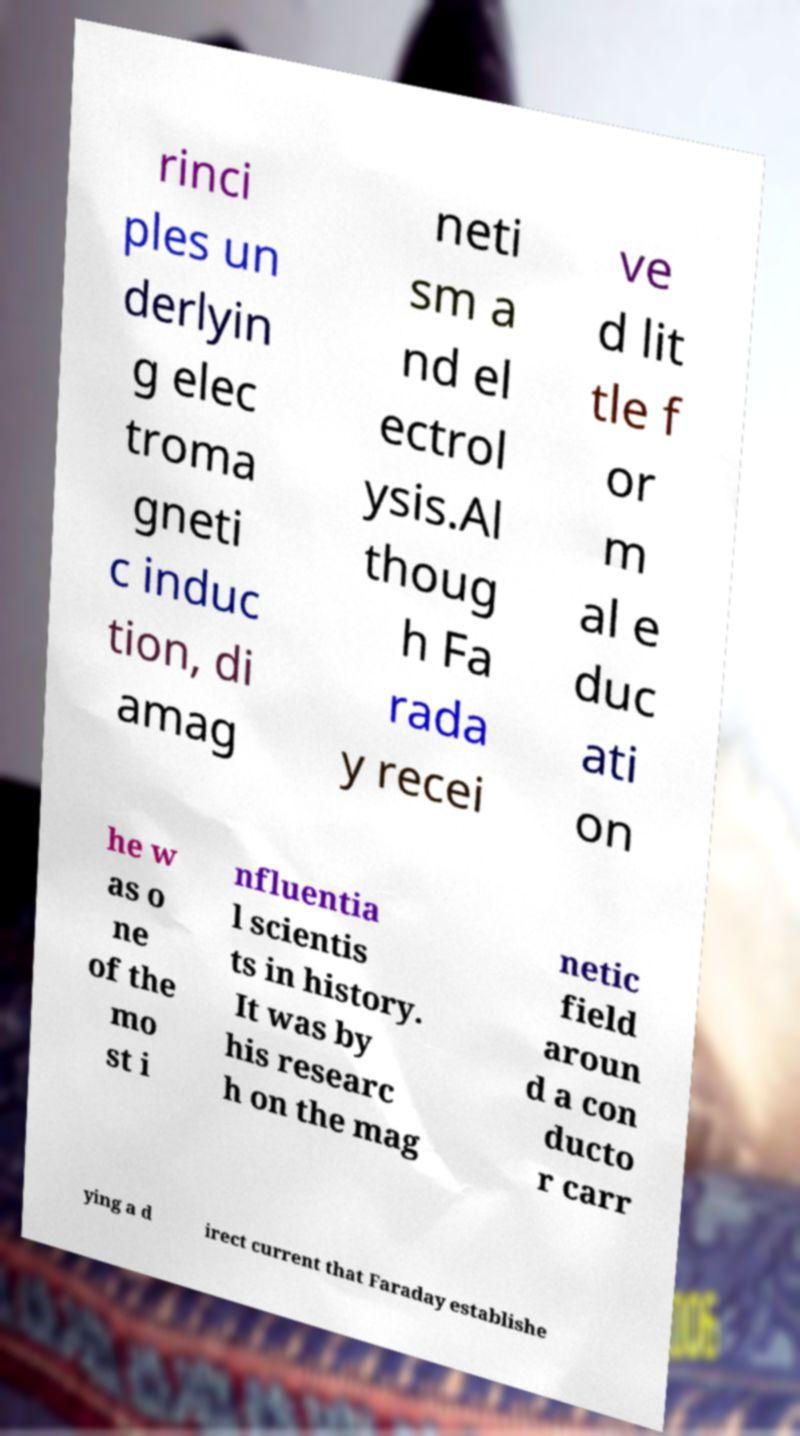Can you read and provide the text displayed in the image?This photo seems to have some interesting text. Can you extract and type it out for me? rinci ples un derlyin g elec troma gneti c induc tion, di amag neti sm a nd el ectrol ysis.Al thoug h Fa rada y recei ve d lit tle f or m al e duc ati on he w as o ne of the mo st i nfluentia l scientis ts in history. It was by his researc h on the mag netic field aroun d a con ducto r carr ying a d irect current that Faraday establishe 